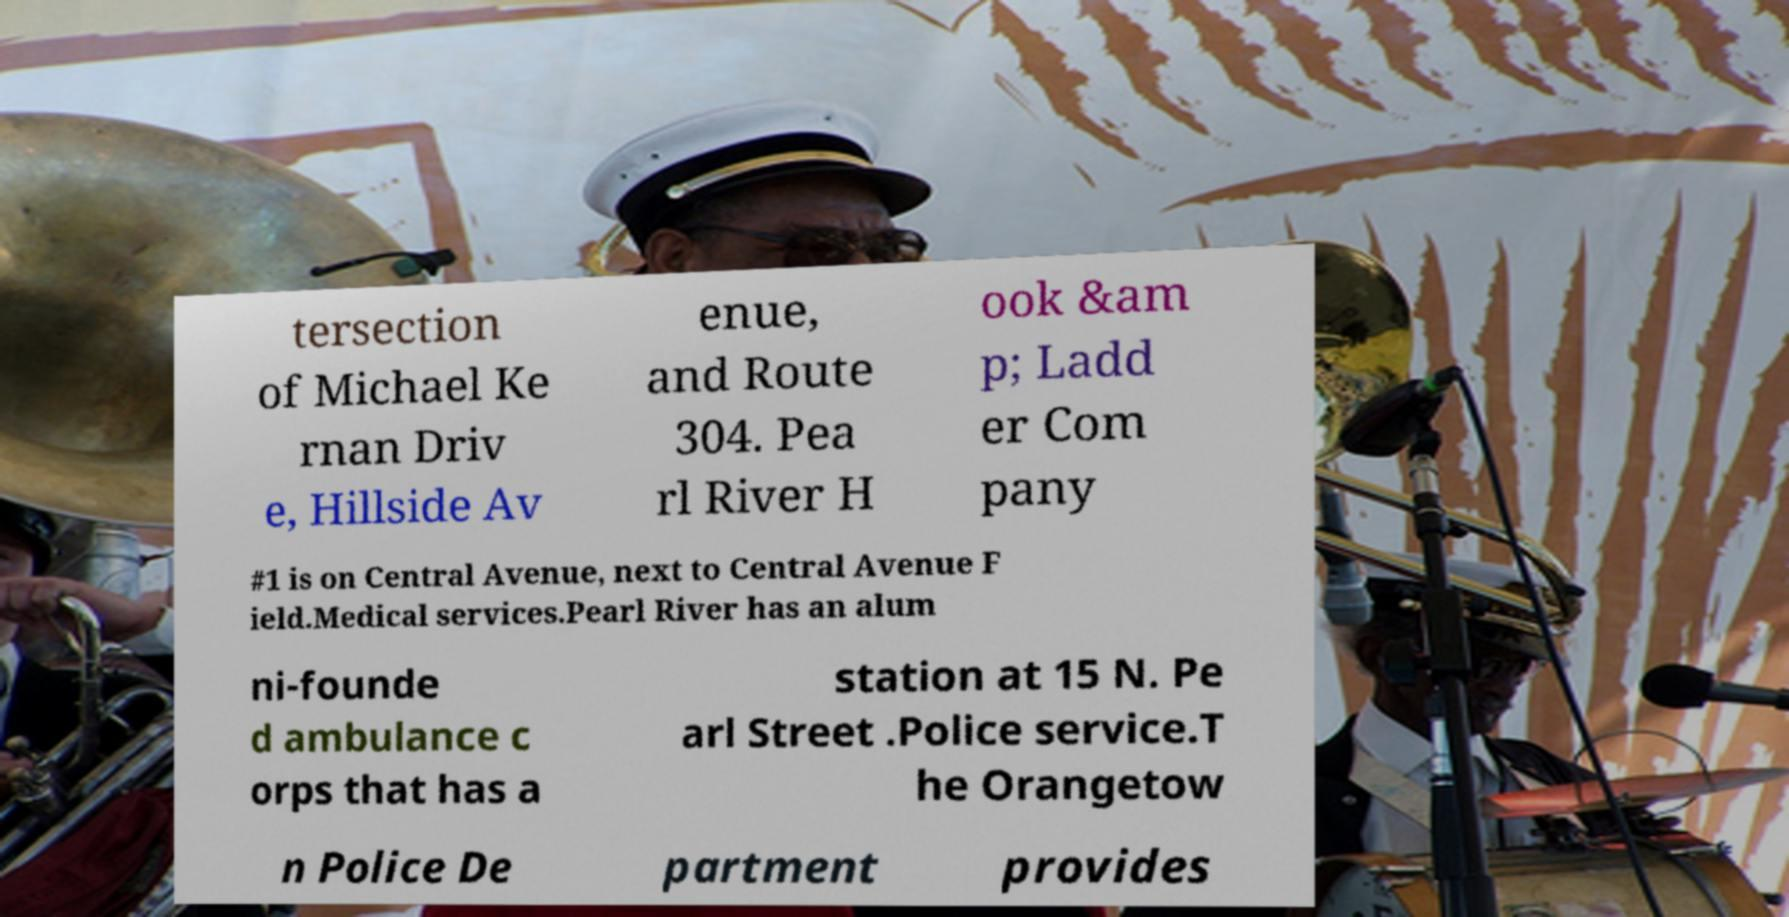Could you assist in decoding the text presented in this image and type it out clearly? tersection of Michael Ke rnan Driv e, Hillside Av enue, and Route 304. Pea rl River H ook &am p; Ladd er Com pany #1 is on Central Avenue, next to Central Avenue F ield.Medical services.Pearl River has an alum ni-founde d ambulance c orps that has a station at 15 N. Pe arl Street .Police service.T he Orangetow n Police De partment provides 